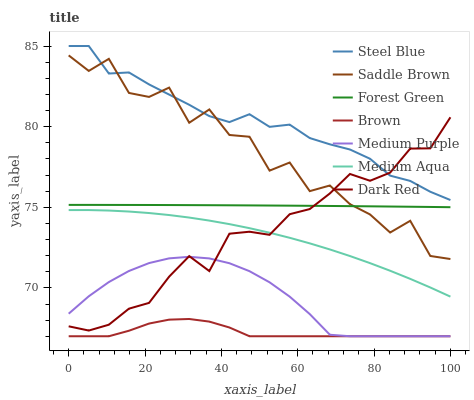Does Brown have the minimum area under the curve?
Answer yes or no. Yes. Does Steel Blue have the maximum area under the curve?
Answer yes or no. Yes. Does Dark Red have the minimum area under the curve?
Answer yes or no. No. Does Dark Red have the maximum area under the curve?
Answer yes or no. No. Is Forest Green the smoothest?
Answer yes or no. Yes. Is Saddle Brown the roughest?
Answer yes or no. Yes. Is Dark Red the smoothest?
Answer yes or no. No. Is Dark Red the roughest?
Answer yes or no. No. Does Brown have the lowest value?
Answer yes or no. Yes. Does Dark Red have the lowest value?
Answer yes or no. No. Does Steel Blue have the highest value?
Answer yes or no. Yes. Does Dark Red have the highest value?
Answer yes or no. No. Is Medium Purple less than Saddle Brown?
Answer yes or no. Yes. Is Steel Blue greater than Brown?
Answer yes or no. Yes. Does Saddle Brown intersect Steel Blue?
Answer yes or no. Yes. Is Saddle Brown less than Steel Blue?
Answer yes or no. No. Is Saddle Brown greater than Steel Blue?
Answer yes or no. No. Does Medium Purple intersect Saddle Brown?
Answer yes or no. No. 